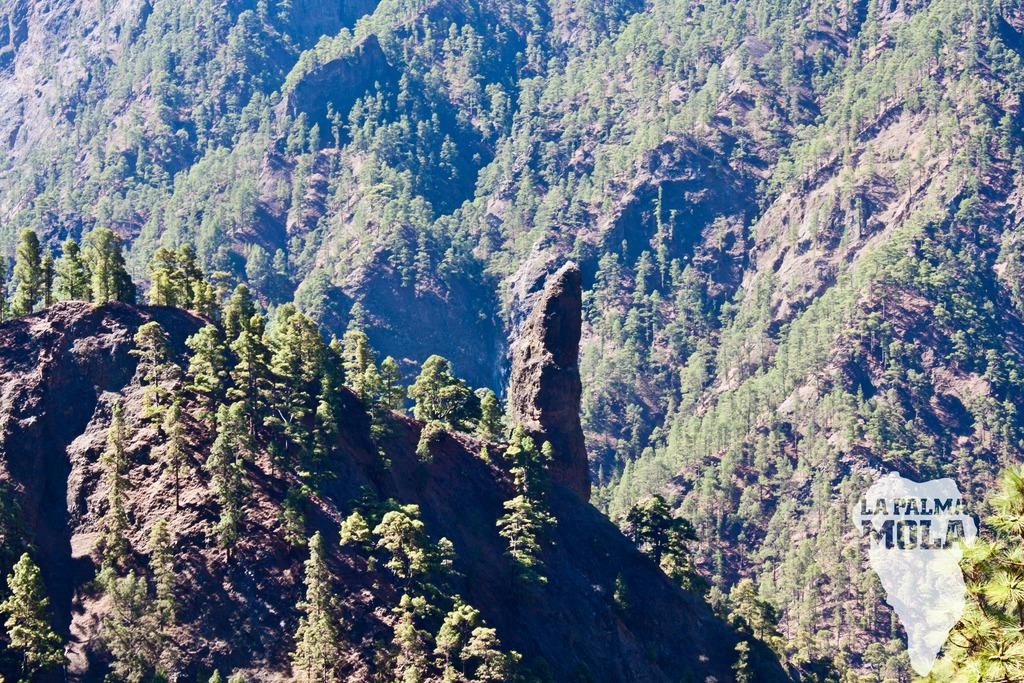What type of view is shown in the image? The image is an aerial view. What natural features can be seen in the image? There are hills and trees visible in the image. Where is the text and map located in the image? The text and map are in the bottom right corner of the image. What type of lunch is being served in the image? There is no lunch or any food visible in the image. What time of day is depicted in the image? The time of day cannot be determined from the image, as there are no specific clues or indicators present. 